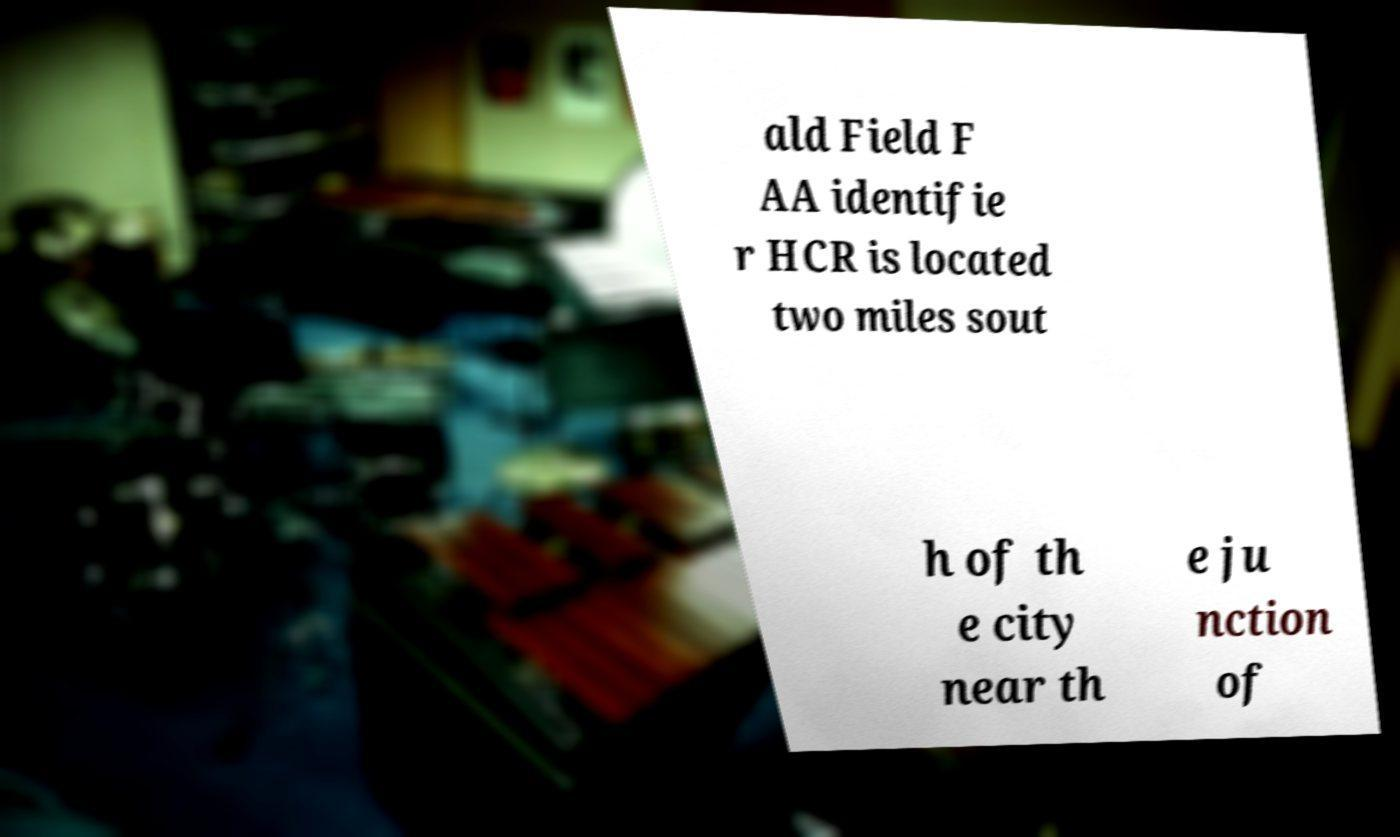I need the written content from this picture converted into text. Can you do that? ald Field F AA identifie r HCR is located two miles sout h of th e city near th e ju nction of 